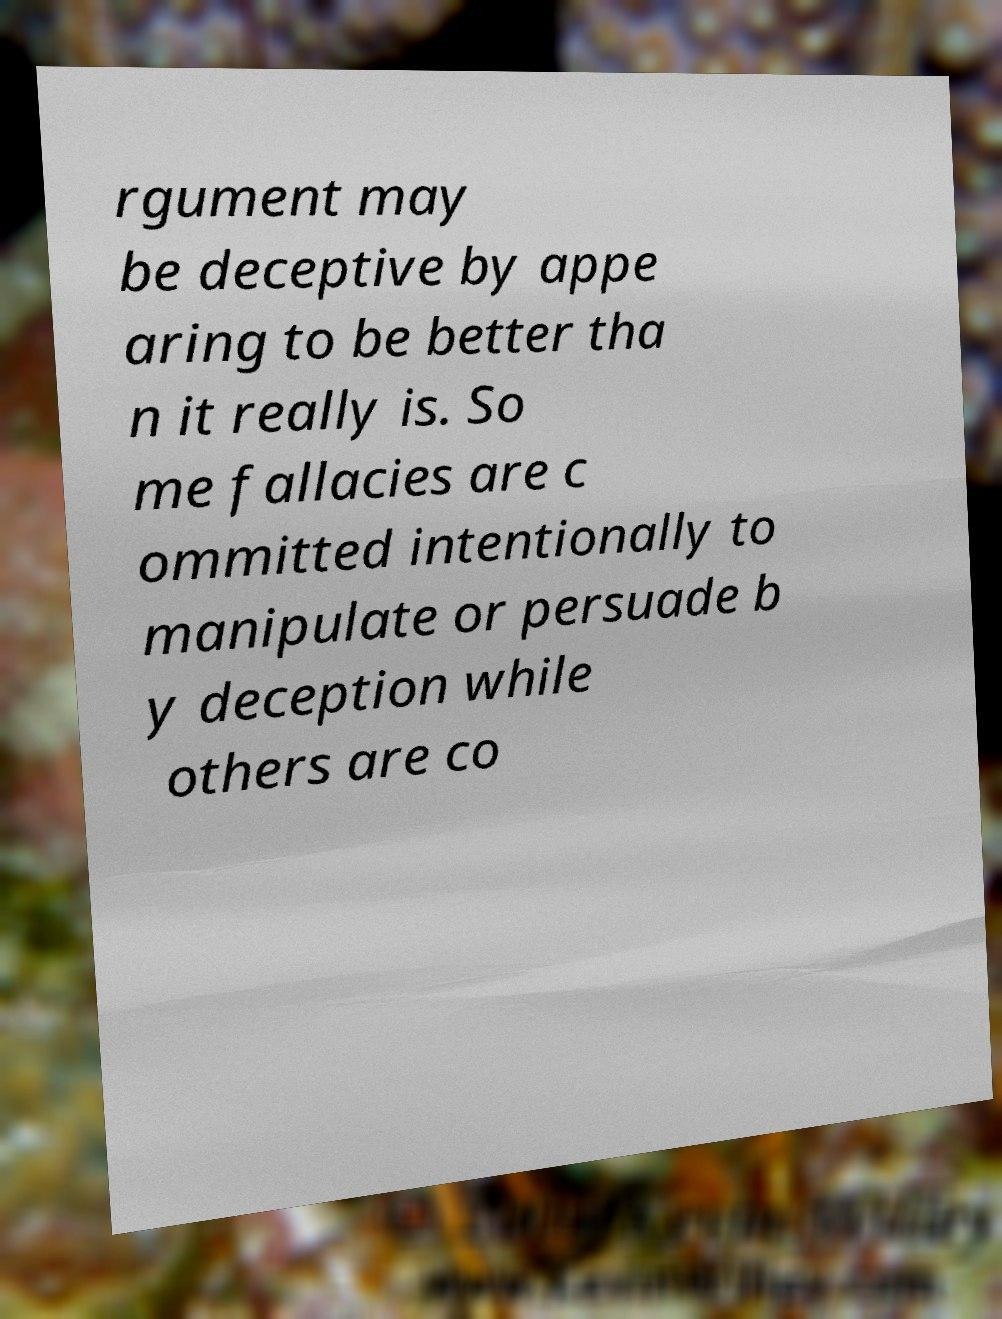Can you read and provide the text displayed in the image?This photo seems to have some interesting text. Can you extract and type it out for me? rgument may be deceptive by appe aring to be better tha n it really is. So me fallacies are c ommitted intentionally to manipulate or persuade b y deception while others are co 